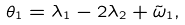<formula> <loc_0><loc_0><loc_500><loc_500>\theta _ { 1 } = \lambda _ { 1 } - 2 \lambda _ { 2 } + \tilde { \omega } _ { 1 } ,</formula> 